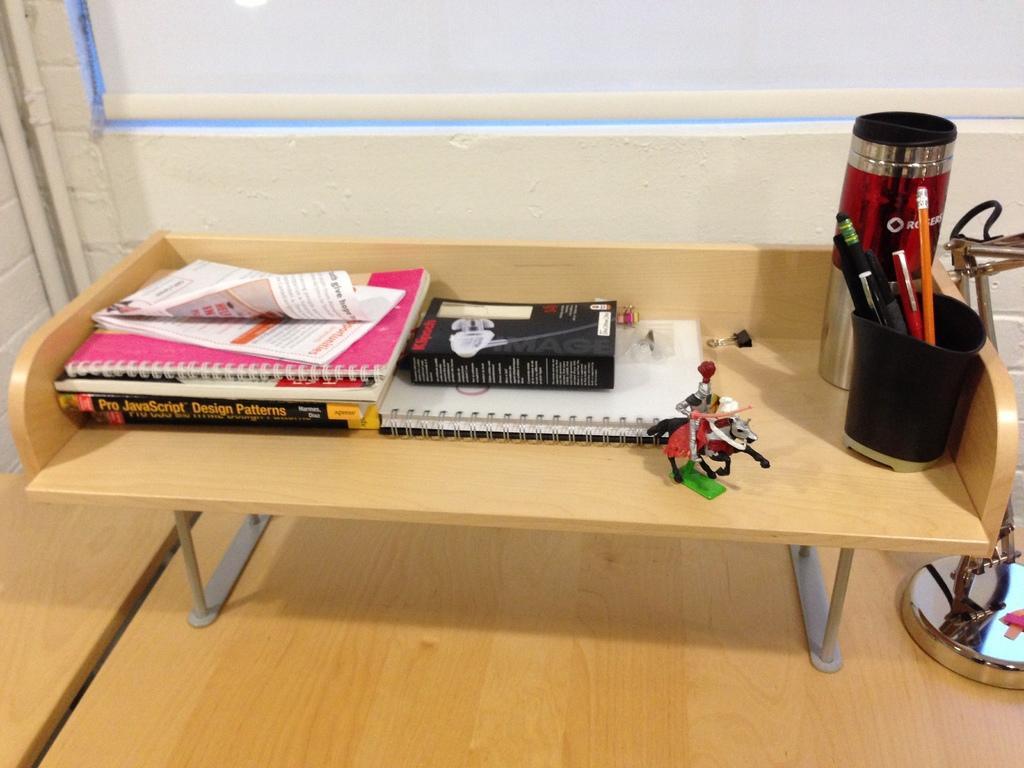Can you describe this image briefly? In the center of the image we can see a table. On the table we can see the books, pages, toy, bottle, pens, pencils, cup. In the background of the image we can see the wall, curtain. On the right side of the image we can see a stand. At the bottom of the image we can see the floor. 